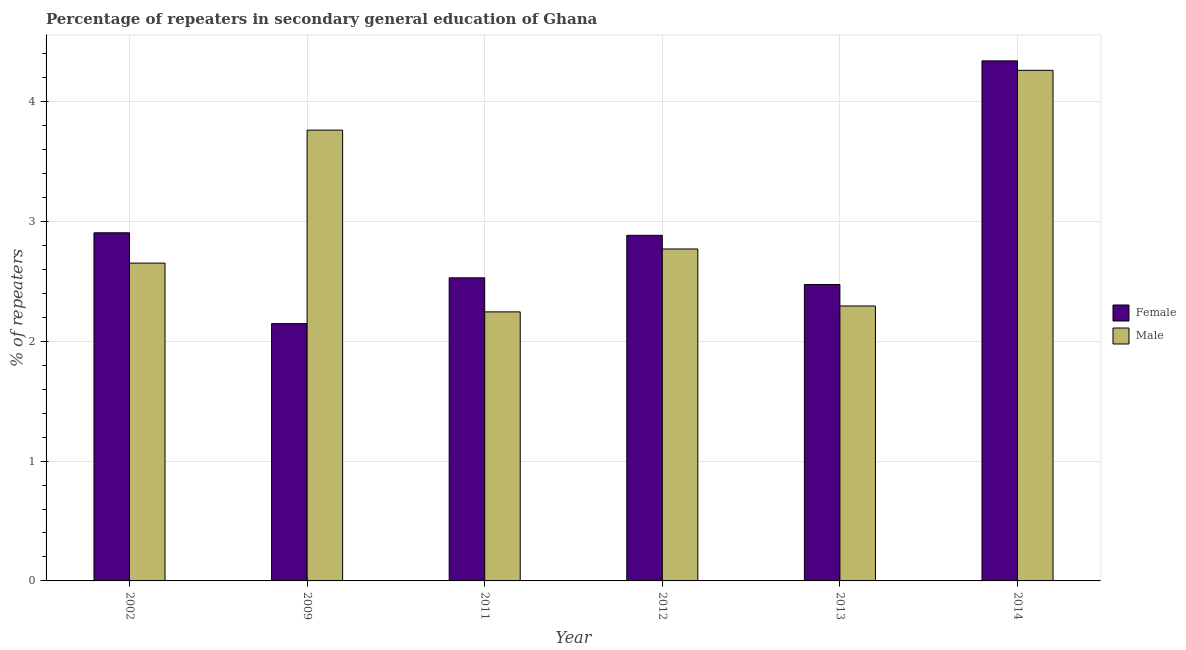How many different coloured bars are there?
Make the answer very short. 2. Are the number of bars per tick equal to the number of legend labels?
Your answer should be very brief. Yes. Are the number of bars on each tick of the X-axis equal?
Your answer should be very brief. Yes. What is the label of the 1st group of bars from the left?
Offer a terse response. 2002. In how many cases, is the number of bars for a given year not equal to the number of legend labels?
Offer a very short reply. 0. What is the percentage of male repeaters in 2013?
Your answer should be compact. 2.29. Across all years, what is the maximum percentage of male repeaters?
Your response must be concise. 4.26. Across all years, what is the minimum percentage of male repeaters?
Provide a succinct answer. 2.24. In which year was the percentage of female repeaters minimum?
Offer a very short reply. 2009. What is the total percentage of male repeaters in the graph?
Keep it short and to the point. 17.98. What is the difference between the percentage of male repeaters in 2012 and that in 2014?
Provide a short and direct response. -1.49. What is the difference between the percentage of female repeaters in 2011 and the percentage of male repeaters in 2002?
Offer a very short reply. -0.38. What is the average percentage of male repeaters per year?
Offer a terse response. 3. In how many years, is the percentage of male repeaters greater than 0.8 %?
Your response must be concise. 6. What is the ratio of the percentage of female repeaters in 2002 to that in 2013?
Offer a very short reply. 1.17. Is the percentage of male repeaters in 2011 less than that in 2014?
Make the answer very short. Yes. What is the difference between the highest and the second highest percentage of female repeaters?
Your answer should be very brief. 1.43. What is the difference between the highest and the lowest percentage of female repeaters?
Ensure brevity in your answer.  2.19. Is the sum of the percentage of male repeaters in 2009 and 2013 greater than the maximum percentage of female repeaters across all years?
Provide a succinct answer. Yes. What does the 2nd bar from the right in 2011 represents?
Your response must be concise. Female. How many bars are there?
Give a very brief answer. 12. Are all the bars in the graph horizontal?
Make the answer very short. No. Does the graph contain any zero values?
Your response must be concise. No. What is the title of the graph?
Provide a short and direct response. Percentage of repeaters in secondary general education of Ghana. What is the label or title of the Y-axis?
Ensure brevity in your answer.  % of repeaters. What is the % of repeaters in Female in 2002?
Keep it short and to the point. 2.9. What is the % of repeaters of Male in 2002?
Provide a succinct answer. 2.65. What is the % of repeaters in Female in 2009?
Offer a very short reply. 2.15. What is the % of repeaters of Male in 2009?
Ensure brevity in your answer.  3.76. What is the % of repeaters of Female in 2011?
Ensure brevity in your answer.  2.53. What is the % of repeaters in Male in 2011?
Make the answer very short. 2.24. What is the % of repeaters in Female in 2012?
Provide a succinct answer. 2.88. What is the % of repeaters of Male in 2012?
Provide a succinct answer. 2.77. What is the % of repeaters of Female in 2013?
Ensure brevity in your answer.  2.47. What is the % of repeaters in Male in 2013?
Keep it short and to the point. 2.29. What is the % of repeaters in Female in 2014?
Your answer should be compact. 4.34. What is the % of repeaters in Male in 2014?
Provide a short and direct response. 4.26. Across all years, what is the maximum % of repeaters of Female?
Make the answer very short. 4.34. Across all years, what is the maximum % of repeaters of Male?
Offer a terse response. 4.26. Across all years, what is the minimum % of repeaters in Female?
Provide a succinct answer. 2.15. Across all years, what is the minimum % of repeaters in Male?
Keep it short and to the point. 2.24. What is the total % of repeaters of Female in the graph?
Give a very brief answer. 17.27. What is the total % of repeaters of Male in the graph?
Provide a succinct answer. 17.98. What is the difference between the % of repeaters of Female in 2002 and that in 2009?
Ensure brevity in your answer.  0.76. What is the difference between the % of repeaters in Male in 2002 and that in 2009?
Keep it short and to the point. -1.11. What is the difference between the % of repeaters in Female in 2002 and that in 2011?
Your response must be concise. 0.38. What is the difference between the % of repeaters of Male in 2002 and that in 2011?
Keep it short and to the point. 0.41. What is the difference between the % of repeaters in Female in 2002 and that in 2012?
Offer a terse response. 0.02. What is the difference between the % of repeaters of Male in 2002 and that in 2012?
Provide a succinct answer. -0.12. What is the difference between the % of repeaters of Female in 2002 and that in 2013?
Give a very brief answer. 0.43. What is the difference between the % of repeaters in Male in 2002 and that in 2013?
Provide a succinct answer. 0.36. What is the difference between the % of repeaters in Female in 2002 and that in 2014?
Offer a terse response. -1.43. What is the difference between the % of repeaters of Male in 2002 and that in 2014?
Offer a very short reply. -1.61. What is the difference between the % of repeaters in Female in 2009 and that in 2011?
Make the answer very short. -0.38. What is the difference between the % of repeaters of Male in 2009 and that in 2011?
Offer a very short reply. 1.52. What is the difference between the % of repeaters of Female in 2009 and that in 2012?
Provide a short and direct response. -0.74. What is the difference between the % of repeaters in Female in 2009 and that in 2013?
Provide a succinct answer. -0.33. What is the difference between the % of repeaters of Male in 2009 and that in 2013?
Your answer should be compact. 1.47. What is the difference between the % of repeaters of Female in 2009 and that in 2014?
Your answer should be compact. -2.19. What is the difference between the % of repeaters in Male in 2009 and that in 2014?
Give a very brief answer. -0.5. What is the difference between the % of repeaters in Female in 2011 and that in 2012?
Your response must be concise. -0.35. What is the difference between the % of repeaters of Male in 2011 and that in 2012?
Your response must be concise. -0.52. What is the difference between the % of repeaters of Female in 2011 and that in 2013?
Offer a terse response. 0.06. What is the difference between the % of repeaters of Male in 2011 and that in 2013?
Provide a succinct answer. -0.05. What is the difference between the % of repeaters in Female in 2011 and that in 2014?
Provide a short and direct response. -1.81. What is the difference between the % of repeaters of Male in 2011 and that in 2014?
Offer a very short reply. -2.02. What is the difference between the % of repeaters in Female in 2012 and that in 2013?
Provide a succinct answer. 0.41. What is the difference between the % of repeaters in Male in 2012 and that in 2013?
Give a very brief answer. 0.48. What is the difference between the % of repeaters in Female in 2012 and that in 2014?
Keep it short and to the point. -1.46. What is the difference between the % of repeaters of Male in 2012 and that in 2014?
Offer a very short reply. -1.49. What is the difference between the % of repeaters of Female in 2013 and that in 2014?
Provide a short and direct response. -1.87. What is the difference between the % of repeaters in Male in 2013 and that in 2014?
Ensure brevity in your answer.  -1.97. What is the difference between the % of repeaters in Female in 2002 and the % of repeaters in Male in 2009?
Make the answer very short. -0.86. What is the difference between the % of repeaters of Female in 2002 and the % of repeaters of Male in 2011?
Provide a succinct answer. 0.66. What is the difference between the % of repeaters of Female in 2002 and the % of repeaters of Male in 2012?
Ensure brevity in your answer.  0.14. What is the difference between the % of repeaters of Female in 2002 and the % of repeaters of Male in 2013?
Keep it short and to the point. 0.61. What is the difference between the % of repeaters of Female in 2002 and the % of repeaters of Male in 2014?
Provide a short and direct response. -1.36. What is the difference between the % of repeaters of Female in 2009 and the % of repeaters of Male in 2011?
Keep it short and to the point. -0.1. What is the difference between the % of repeaters in Female in 2009 and the % of repeaters in Male in 2012?
Provide a short and direct response. -0.62. What is the difference between the % of repeaters of Female in 2009 and the % of repeaters of Male in 2013?
Your response must be concise. -0.15. What is the difference between the % of repeaters of Female in 2009 and the % of repeaters of Male in 2014?
Keep it short and to the point. -2.11. What is the difference between the % of repeaters of Female in 2011 and the % of repeaters of Male in 2012?
Make the answer very short. -0.24. What is the difference between the % of repeaters of Female in 2011 and the % of repeaters of Male in 2013?
Offer a terse response. 0.23. What is the difference between the % of repeaters of Female in 2011 and the % of repeaters of Male in 2014?
Provide a short and direct response. -1.73. What is the difference between the % of repeaters of Female in 2012 and the % of repeaters of Male in 2013?
Provide a succinct answer. 0.59. What is the difference between the % of repeaters in Female in 2012 and the % of repeaters in Male in 2014?
Give a very brief answer. -1.38. What is the difference between the % of repeaters of Female in 2013 and the % of repeaters of Male in 2014?
Offer a very short reply. -1.79. What is the average % of repeaters of Female per year?
Your response must be concise. 2.88. What is the average % of repeaters in Male per year?
Offer a terse response. 3. In the year 2002, what is the difference between the % of repeaters of Female and % of repeaters of Male?
Your response must be concise. 0.25. In the year 2009, what is the difference between the % of repeaters in Female and % of repeaters in Male?
Your answer should be very brief. -1.61. In the year 2011, what is the difference between the % of repeaters in Female and % of repeaters in Male?
Provide a succinct answer. 0.28. In the year 2012, what is the difference between the % of repeaters of Female and % of repeaters of Male?
Provide a succinct answer. 0.11. In the year 2013, what is the difference between the % of repeaters of Female and % of repeaters of Male?
Your answer should be compact. 0.18. In the year 2014, what is the difference between the % of repeaters of Female and % of repeaters of Male?
Your response must be concise. 0.08. What is the ratio of the % of repeaters of Female in 2002 to that in 2009?
Offer a very short reply. 1.35. What is the ratio of the % of repeaters in Male in 2002 to that in 2009?
Your response must be concise. 0.7. What is the ratio of the % of repeaters in Female in 2002 to that in 2011?
Your response must be concise. 1.15. What is the ratio of the % of repeaters in Male in 2002 to that in 2011?
Keep it short and to the point. 1.18. What is the ratio of the % of repeaters of Female in 2002 to that in 2012?
Provide a short and direct response. 1.01. What is the ratio of the % of repeaters in Male in 2002 to that in 2012?
Your answer should be compact. 0.96. What is the ratio of the % of repeaters in Female in 2002 to that in 2013?
Make the answer very short. 1.17. What is the ratio of the % of repeaters in Male in 2002 to that in 2013?
Offer a terse response. 1.16. What is the ratio of the % of repeaters in Female in 2002 to that in 2014?
Offer a very short reply. 0.67. What is the ratio of the % of repeaters in Male in 2002 to that in 2014?
Provide a short and direct response. 0.62. What is the ratio of the % of repeaters of Female in 2009 to that in 2011?
Ensure brevity in your answer.  0.85. What is the ratio of the % of repeaters in Male in 2009 to that in 2011?
Provide a succinct answer. 1.68. What is the ratio of the % of repeaters in Female in 2009 to that in 2012?
Give a very brief answer. 0.74. What is the ratio of the % of repeaters in Male in 2009 to that in 2012?
Your answer should be very brief. 1.36. What is the ratio of the % of repeaters of Female in 2009 to that in 2013?
Your answer should be compact. 0.87. What is the ratio of the % of repeaters of Male in 2009 to that in 2013?
Offer a terse response. 1.64. What is the ratio of the % of repeaters in Female in 2009 to that in 2014?
Your response must be concise. 0.49. What is the ratio of the % of repeaters of Male in 2009 to that in 2014?
Offer a terse response. 0.88. What is the ratio of the % of repeaters of Female in 2011 to that in 2012?
Make the answer very short. 0.88. What is the ratio of the % of repeaters of Male in 2011 to that in 2012?
Your response must be concise. 0.81. What is the ratio of the % of repeaters in Female in 2011 to that in 2013?
Make the answer very short. 1.02. What is the ratio of the % of repeaters of Male in 2011 to that in 2013?
Ensure brevity in your answer.  0.98. What is the ratio of the % of repeaters in Female in 2011 to that in 2014?
Provide a succinct answer. 0.58. What is the ratio of the % of repeaters in Male in 2011 to that in 2014?
Offer a very short reply. 0.53. What is the ratio of the % of repeaters in Female in 2012 to that in 2013?
Keep it short and to the point. 1.17. What is the ratio of the % of repeaters of Male in 2012 to that in 2013?
Your response must be concise. 1.21. What is the ratio of the % of repeaters in Female in 2012 to that in 2014?
Provide a short and direct response. 0.66. What is the ratio of the % of repeaters in Male in 2012 to that in 2014?
Provide a succinct answer. 0.65. What is the ratio of the % of repeaters of Female in 2013 to that in 2014?
Your answer should be compact. 0.57. What is the ratio of the % of repeaters in Male in 2013 to that in 2014?
Keep it short and to the point. 0.54. What is the difference between the highest and the second highest % of repeaters of Female?
Offer a terse response. 1.43. What is the difference between the highest and the second highest % of repeaters in Male?
Offer a very short reply. 0.5. What is the difference between the highest and the lowest % of repeaters of Female?
Give a very brief answer. 2.19. What is the difference between the highest and the lowest % of repeaters of Male?
Offer a terse response. 2.02. 